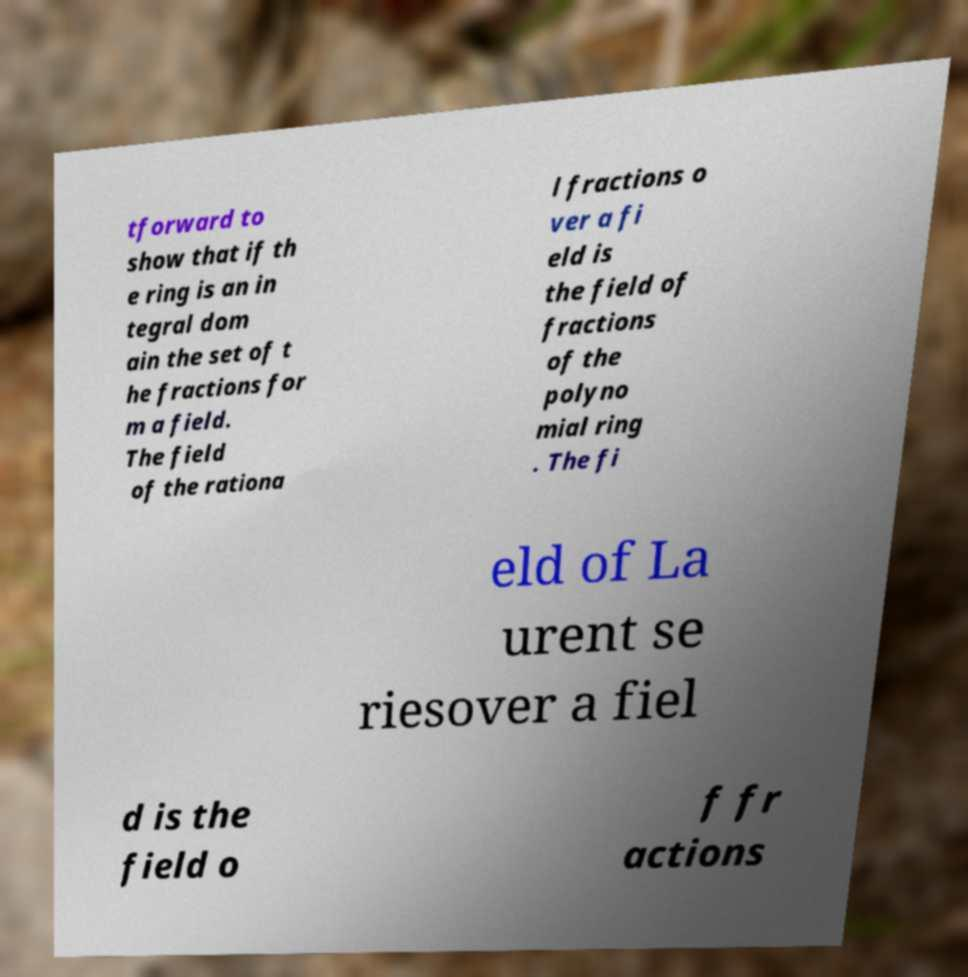What messages or text are displayed in this image? I need them in a readable, typed format. tforward to show that if th e ring is an in tegral dom ain the set of t he fractions for m a field. The field of the rationa l fractions o ver a fi eld is the field of fractions of the polyno mial ring . The fi eld of La urent se riesover a fiel d is the field o f fr actions 